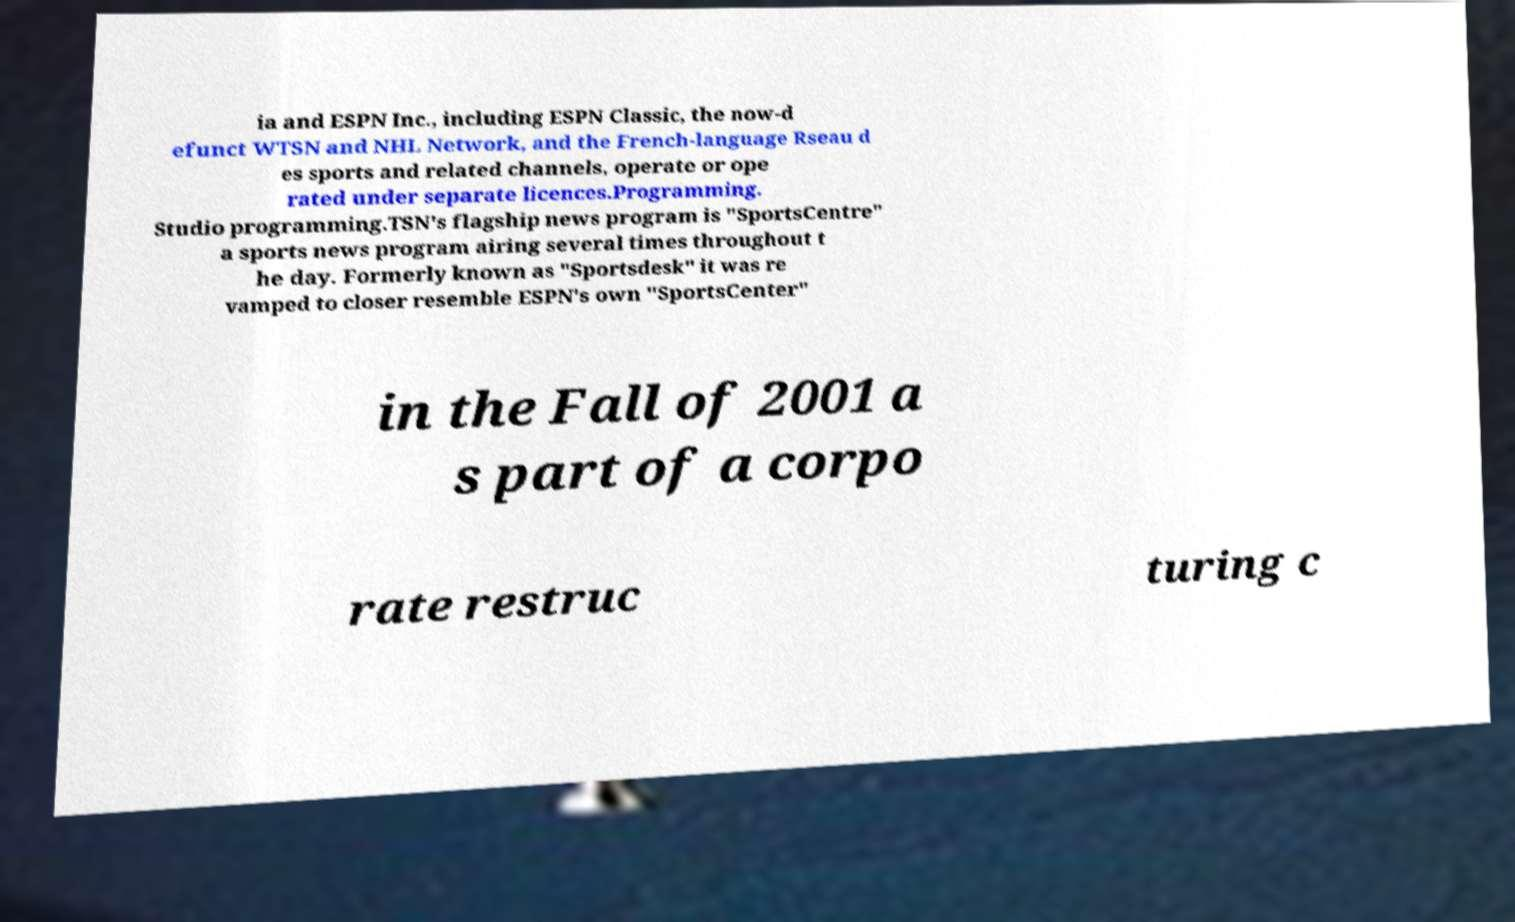Please identify and transcribe the text found in this image. ia and ESPN Inc., including ESPN Classic, the now-d efunct WTSN and NHL Network, and the French-language Rseau d es sports and related channels, operate or ope rated under separate licences.Programming. Studio programming.TSN's flagship news program is "SportsCentre" a sports news program airing several times throughout t he day. Formerly known as "Sportsdesk" it was re vamped to closer resemble ESPN's own "SportsCenter" in the Fall of 2001 a s part of a corpo rate restruc turing c 